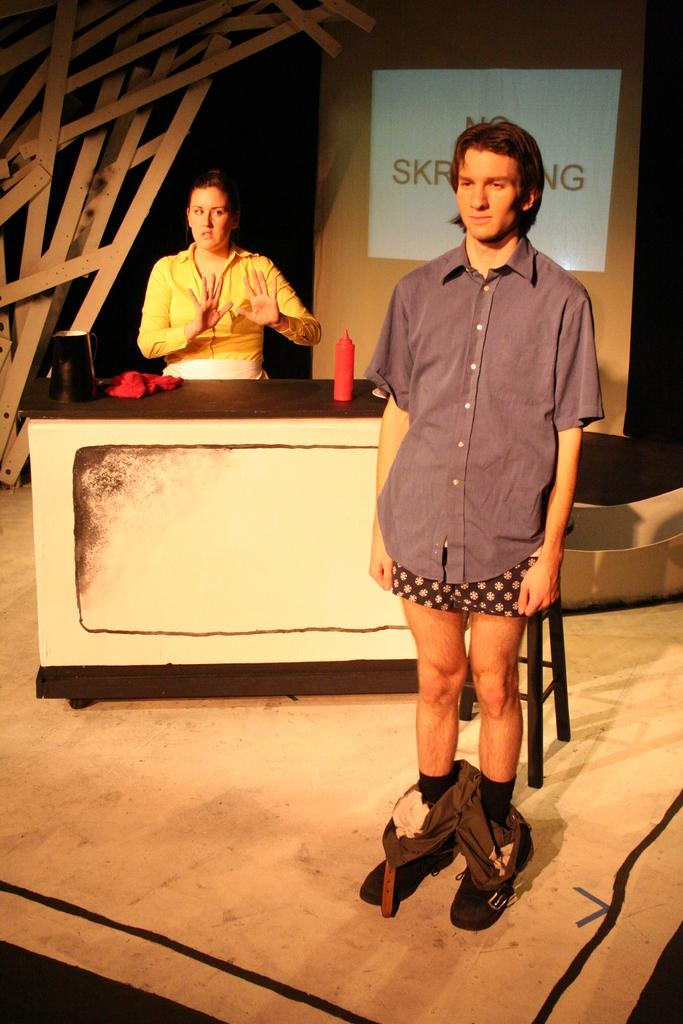What is the gender of the person standing in the image? There is a man standing in the image. Are there any other people in the image besides the man? Yes, there is a woman in the image. What can be seen in the background of the image? There is a table with objects on it, a bottle on the table, and a screen visible in the background. How many eyes does the bottle have in the image? The bottle does not have eyes, as it is an inanimate object. 